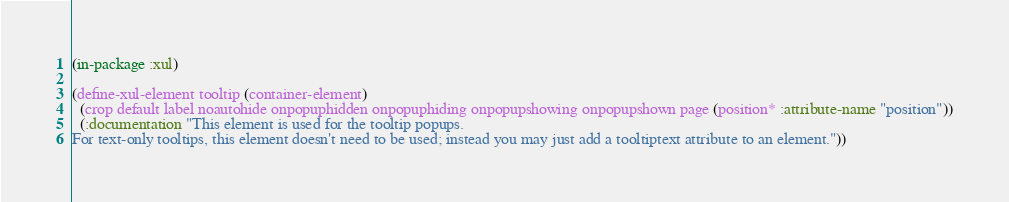<code> <loc_0><loc_0><loc_500><loc_500><_Lisp_>(in-package :xul)

(define-xul-element tooltip (container-element)
  (crop default label noautohide onpopuphidden onpopuphiding onpopupshowing onpopupshown page (position* :attribute-name "position"))
  (:documentation "This element is used for the tooltip popups.
For text-only tooltips, this element doesn't need to be used; instead you may just add a tooltiptext attribute to an element."))
</code> 